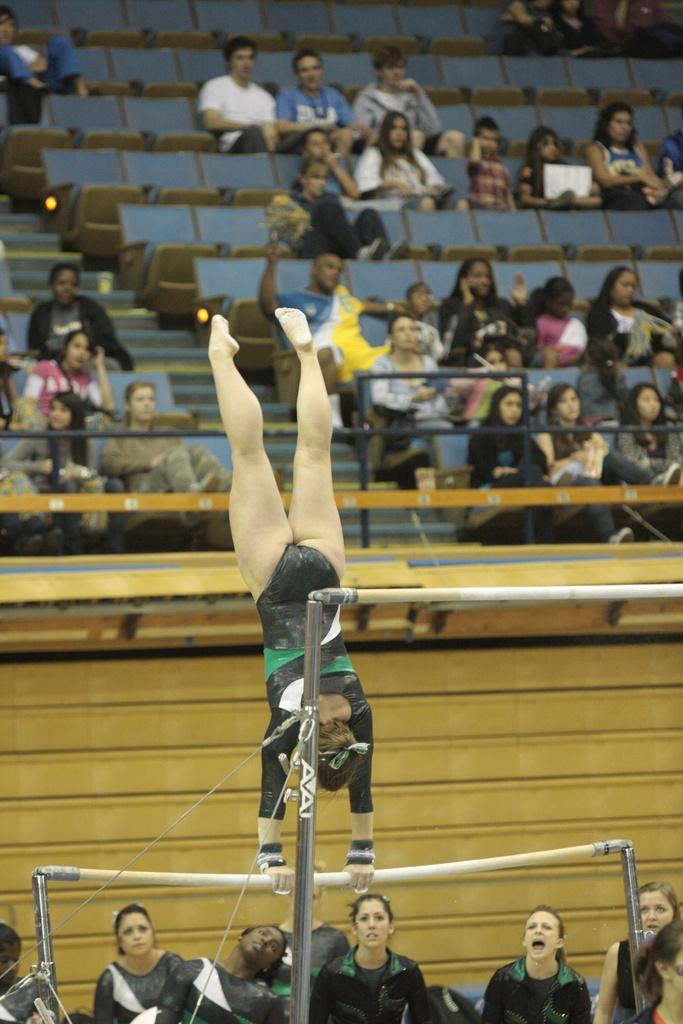<image>
Describe the image concisely. Gymnast performing a trick on a pole that has the letters AA on it. 